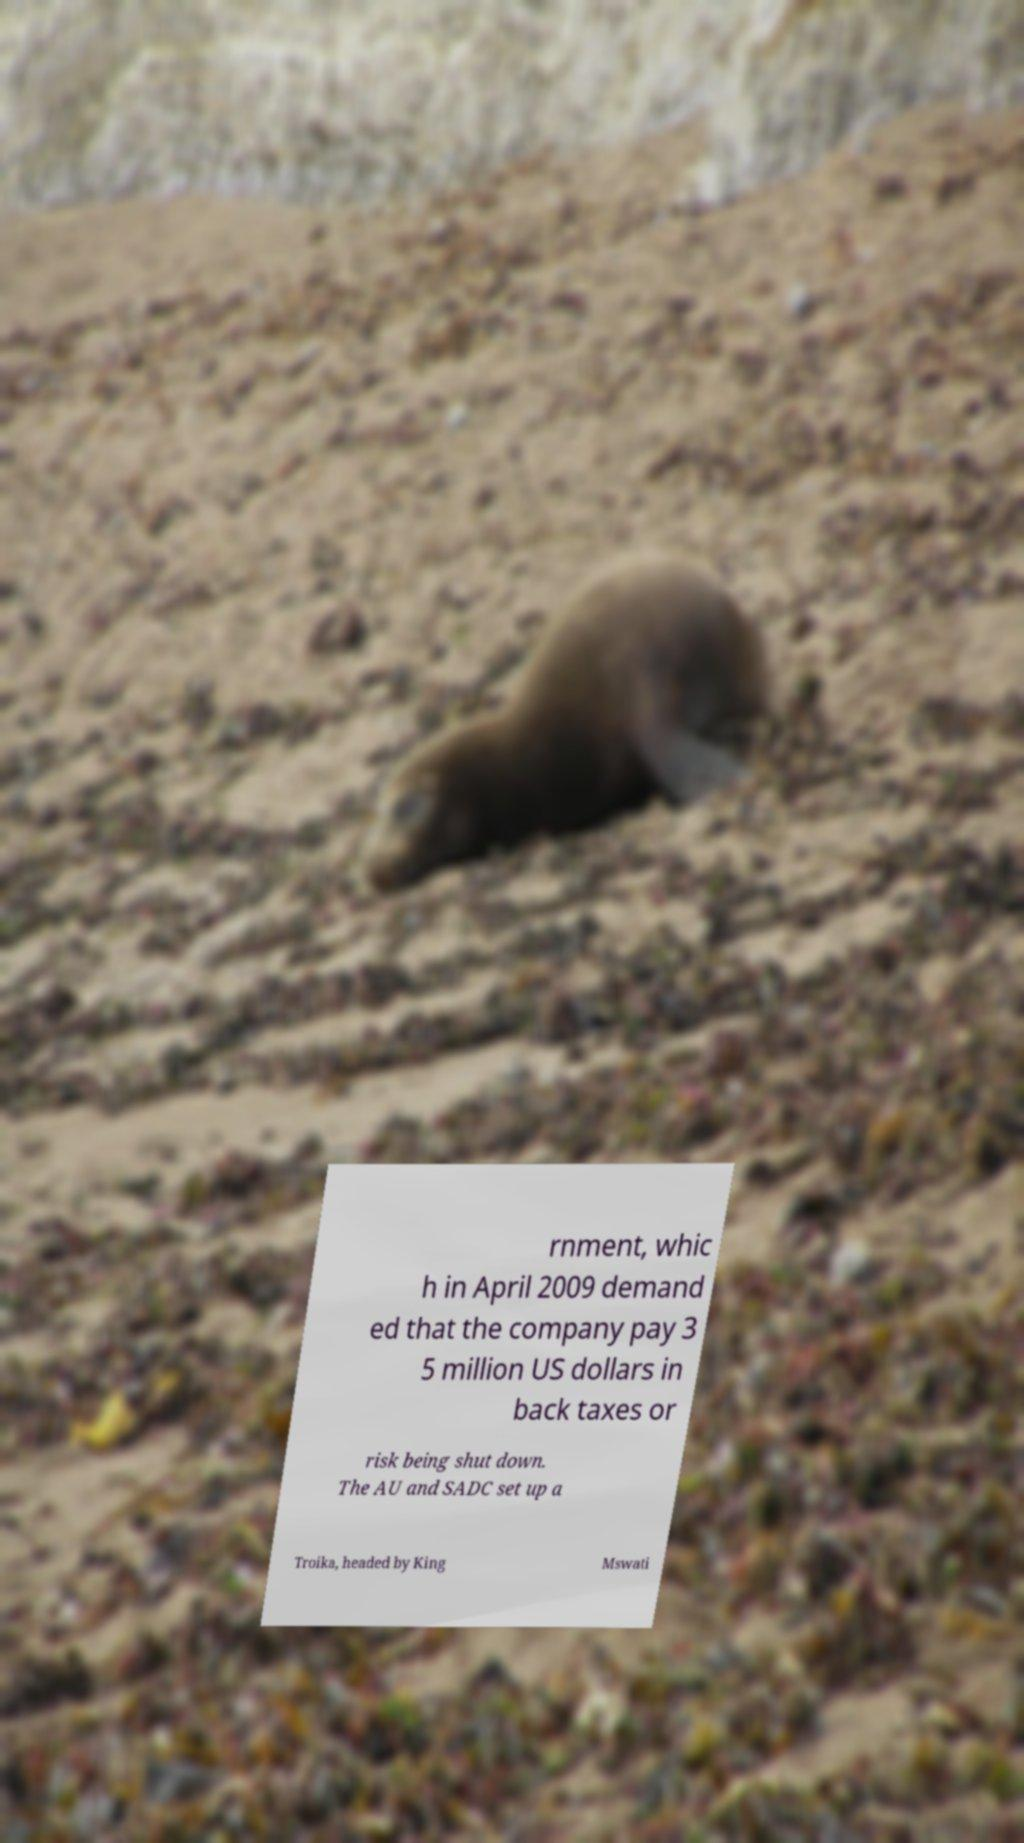Can you read and provide the text displayed in the image?This photo seems to have some interesting text. Can you extract and type it out for me? rnment, whic h in April 2009 demand ed that the company pay 3 5 million US dollars in back taxes or risk being shut down. The AU and SADC set up a Troika, headed by King Mswati 